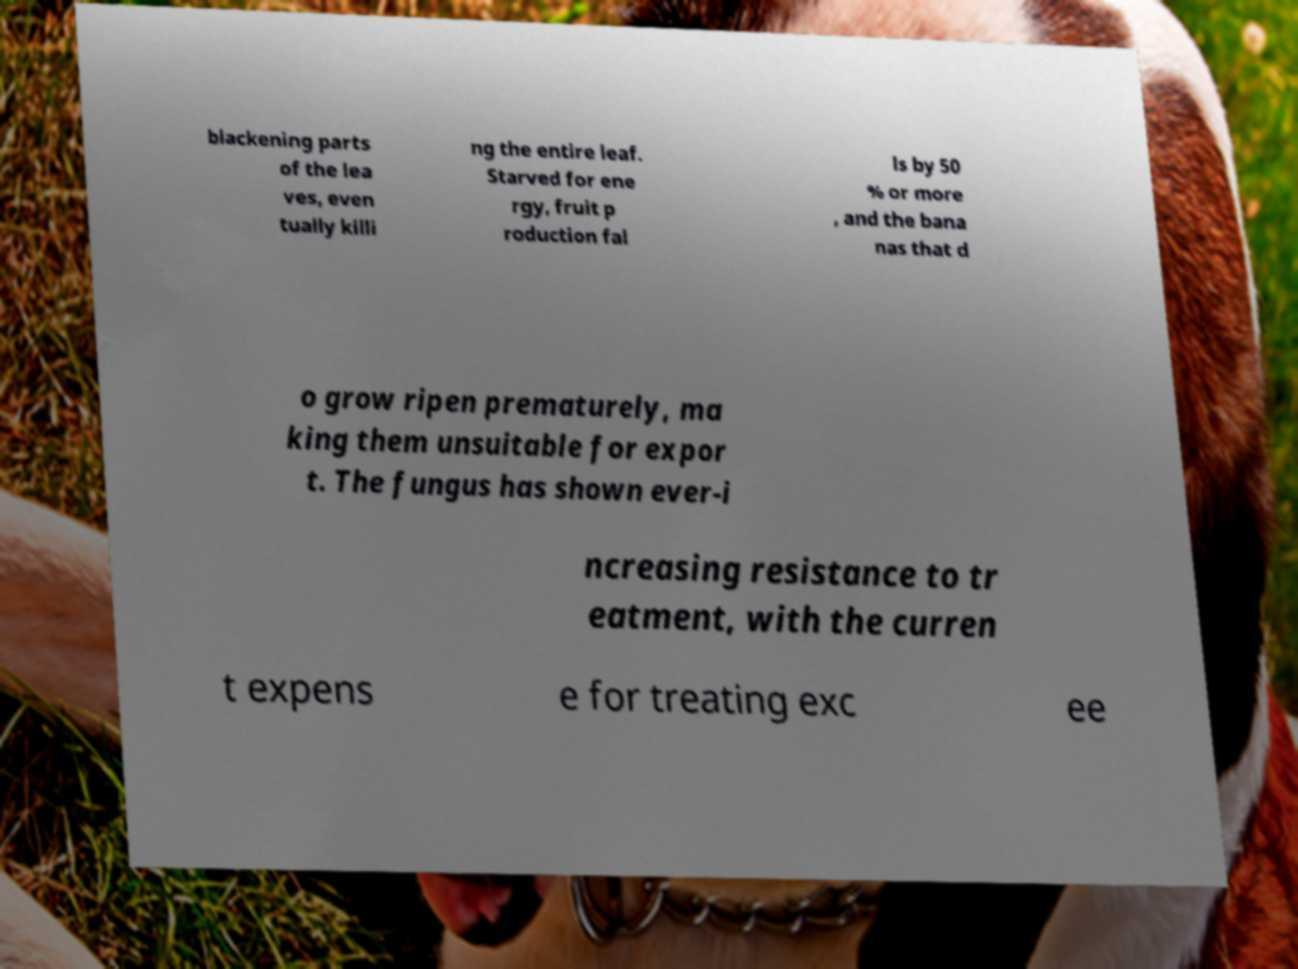Can you read and provide the text displayed in the image?This photo seems to have some interesting text. Can you extract and type it out for me? blackening parts of the lea ves, even tually killi ng the entire leaf. Starved for ene rgy, fruit p roduction fal ls by 50 % or more , and the bana nas that d o grow ripen prematurely, ma king them unsuitable for expor t. The fungus has shown ever-i ncreasing resistance to tr eatment, with the curren t expens e for treating exc ee 